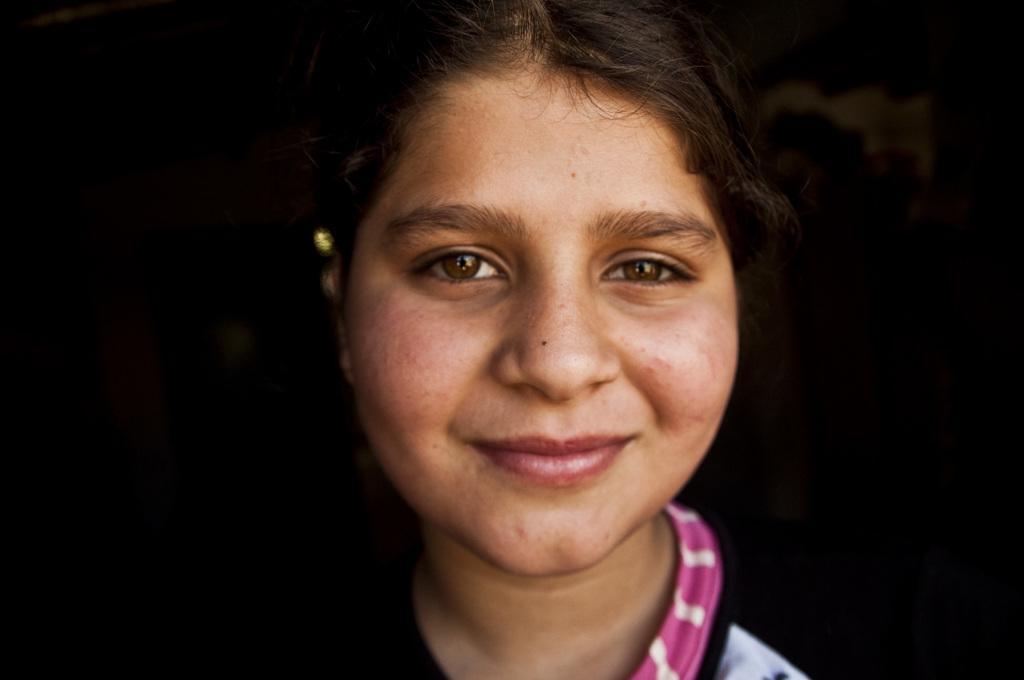Describe this image in one or two sentences. In this picture we can see a woman smiling here, we can see a dark background. 